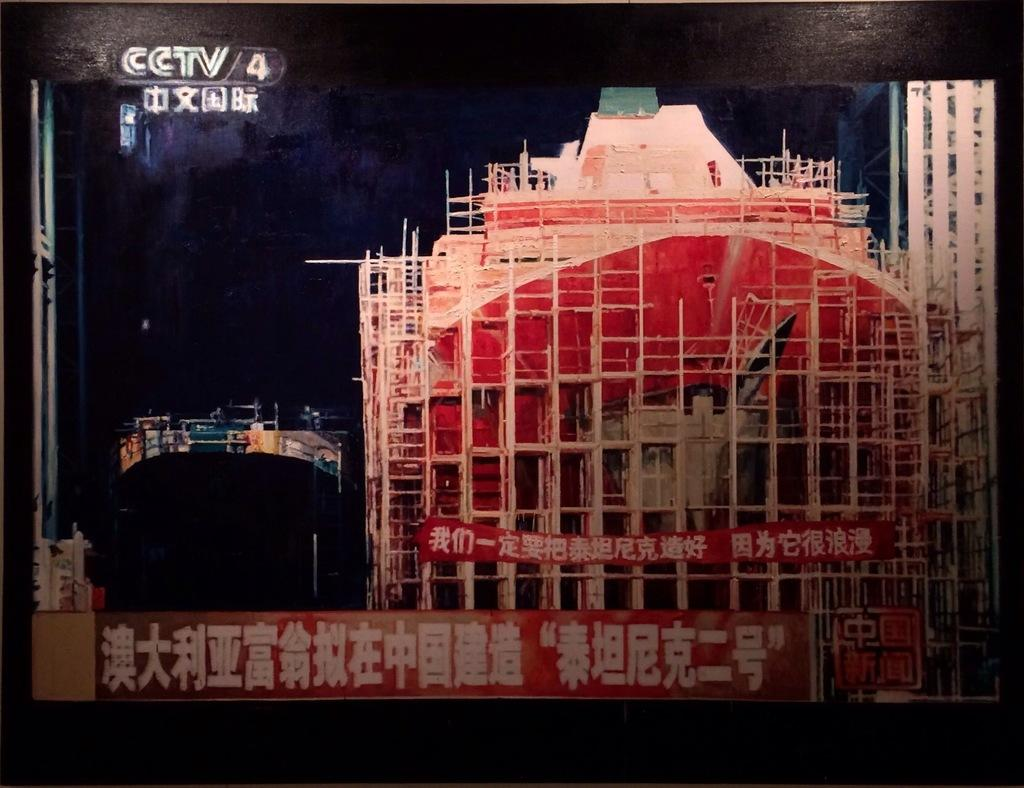What is featured in the image? There is a poster in the image. What type of writing is on the poster? The poster contains Chinese script. What color is the surface at the top and bottom of the poster? There is a black surface at the top and bottom of the poster. What type of cloth is used to cover the aftermath of the event in the image? There is no event or cloth present in the image; it only features a poster with Chinese script and black surfaces at the top and bottom. 